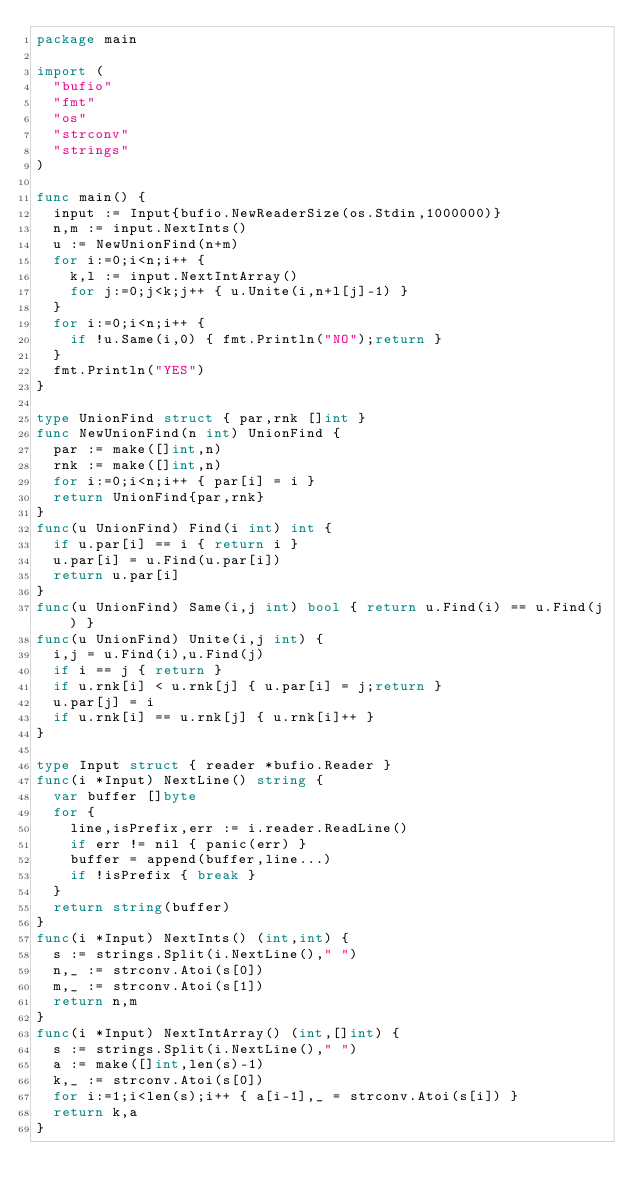Convert code to text. <code><loc_0><loc_0><loc_500><loc_500><_Go_>package main

import (
  "bufio"
  "fmt"
  "os"
  "strconv"
  "strings"
)

func main() {
  input := Input{bufio.NewReaderSize(os.Stdin,1000000)}
  n,m := input.NextInts()
  u := NewUnionFind(n+m)
  for i:=0;i<n;i++ {
    k,l := input.NextIntArray()
    for j:=0;j<k;j++ { u.Unite(i,n+l[j]-1) }
  }
  for i:=0;i<n;i++ {
    if !u.Same(i,0) { fmt.Println("NO");return }
  }
  fmt.Println("YES")
}

type UnionFind struct { par,rnk []int }
func NewUnionFind(n int) UnionFind {
  par := make([]int,n)
  rnk := make([]int,n)
  for i:=0;i<n;i++ { par[i] = i }
  return UnionFind{par,rnk}
}
func(u UnionFind) Find(i int) int {
  if u.par[i] == i { return i }
  u.par[i] = u.Find(u.par[i])
  return u.par[i]
}
func(u UnionFind) Same(i,j int) bool { return u.Find(i) == u.Find(j) }
func(u UnionFind) Unite(i,j int) {
  i,j = u.Find(i),u.Find(j)
  if i == j { return }
  if u.rnk[i] < u.rnk[j] { u.par[i] = j;return }
  u.par[j] = i
  if u.rnk[i] == u.rnk[j] { u.rnk[i]++ }
}

type Input struct { reader *bufio.Reader }
func(i *Input) NextLine() string {
  var buffer []byte
  for {
    line,isPrefix,err := i.reader.ReadLine()
    if err != nil { panic(err) }
    buffer = append(buffer,line...)
    if !isPrefix { break }
  }
  return string(buffer)
}
func(i *Input) NextInts() (int,int) {
  s := strings.Split(i.NextLine()," ")
  n,_ := strconv.Atoi(s[0])
  m,_ := strconv.Atoi(s[1])
  return n,m
}
func(i *Input) NextIntArray() (int,[]int) {
  s := strings.Split(i.NextLine()," ")
  a := make([]int,len(s)-1)
  k,_ := strconv.Atoi(s[0])
  for i:=1;i<len(s);i++ { a[i-1],_ = strconv.Atoi(s[i]) }
  return k,a
}</code> 